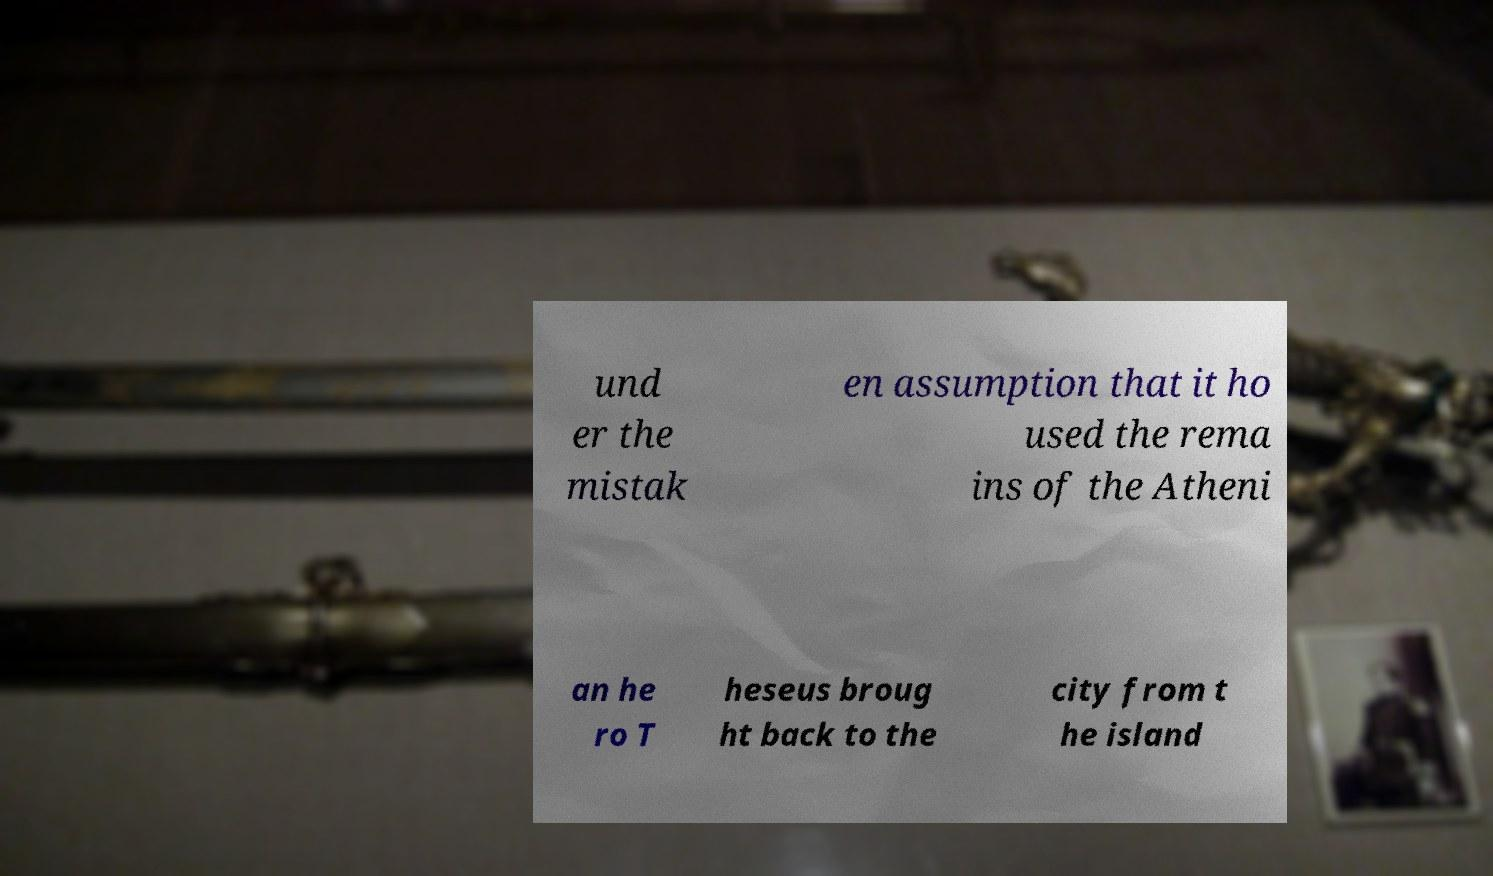Please identify and transcribe the text found in this image. und er the mistak en assumption that it ho used the rema ins of the Atheni an he ro T heseus broug ht back to the city from t he island 